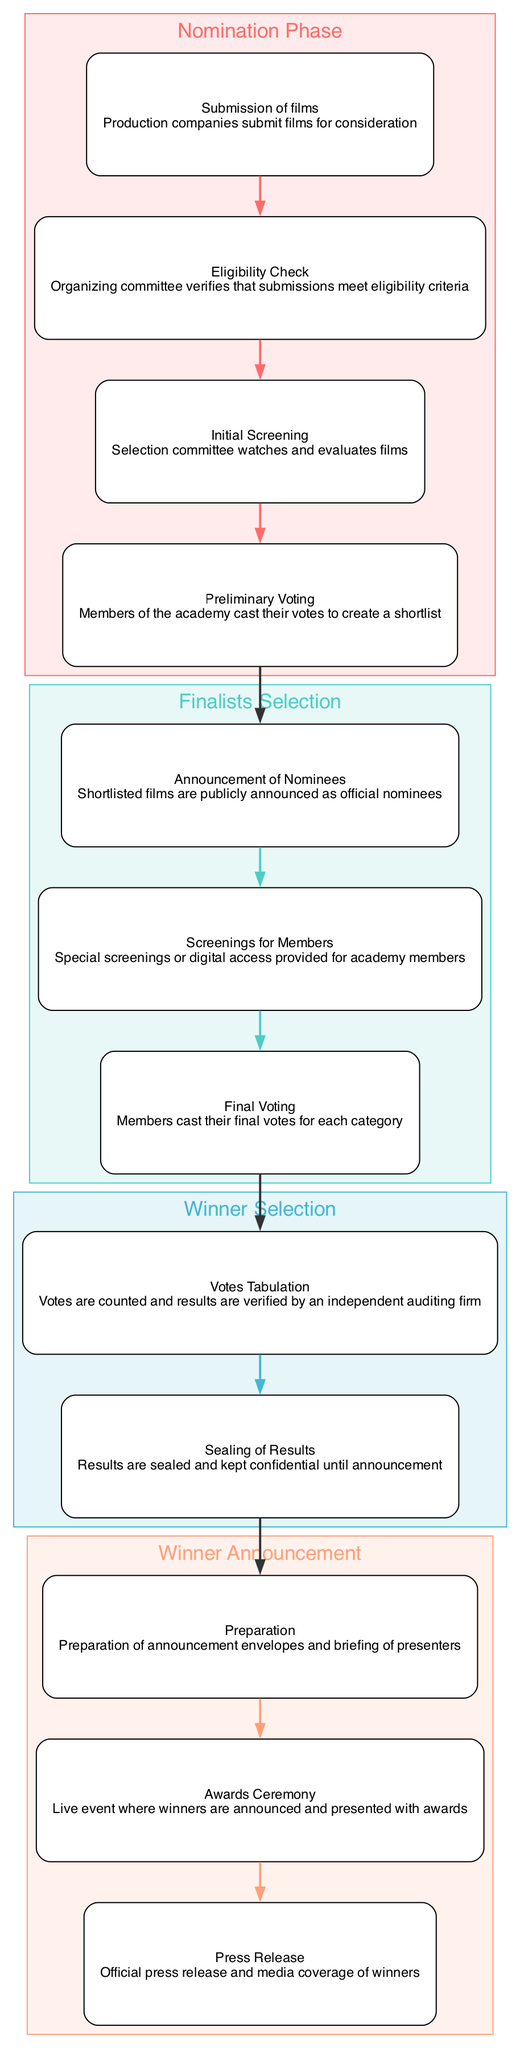What is the first step in the Nomination Phase? The first step listed under the Nomination Phase is "Submission of films," which indicates that production companies submit films for consideration.
Answer: Submission of films How many steps are in the Winner Announcement phase? The Winner Announcement phase includes three distinct steps: Preparation, Awards Ceremony, and Press Release.
Answer: 3 What connects the Initial Screening to Preliminary Voting? The connection between Initial Screening and Preliminary Voting is a direct flow from Initial Screening to Preliminary Voting, indicating that after screening, votes are cast to create a shortlist.
Answer: Preliminary Voting Which phase directly follows the Finalists Selection? The phase that comes directly after Finalists Selection is Winner Selection, as indicated by the connections in the diagram.
Answer: Winner Selection What is the last step in the Winner Selection phase? The final step in the Winner Selection phase is "Sealing of Results," which signifies that results are kept confidential until the announcement.
Answer: Sealing of Results Which step involves screenings for academy members? The step that involves screenings for academy members is called "Screenings for Members," where special screenings or digital access is provided for academy members.
Answer: Screenings for Members What is the purpose of the Votes Tabulation step? The Votes Tabulation step is meant for counting the votes and verifying the results by an independent auditing firm, ensuring accuracy in the award process.
Answer: Counting and verification What is the overall label of the first phase? The overall label of the first phase is "Nomination Phase," indicating the beginning of the award process.
Answer: Nomination Phase What happens immediately after the Nomination Phase? Immediately after the Nomination Phase, the next phase is Finalists Selection, indicating the transition from nominations to identifying the official nominees.
Answer: Finalists Selection 